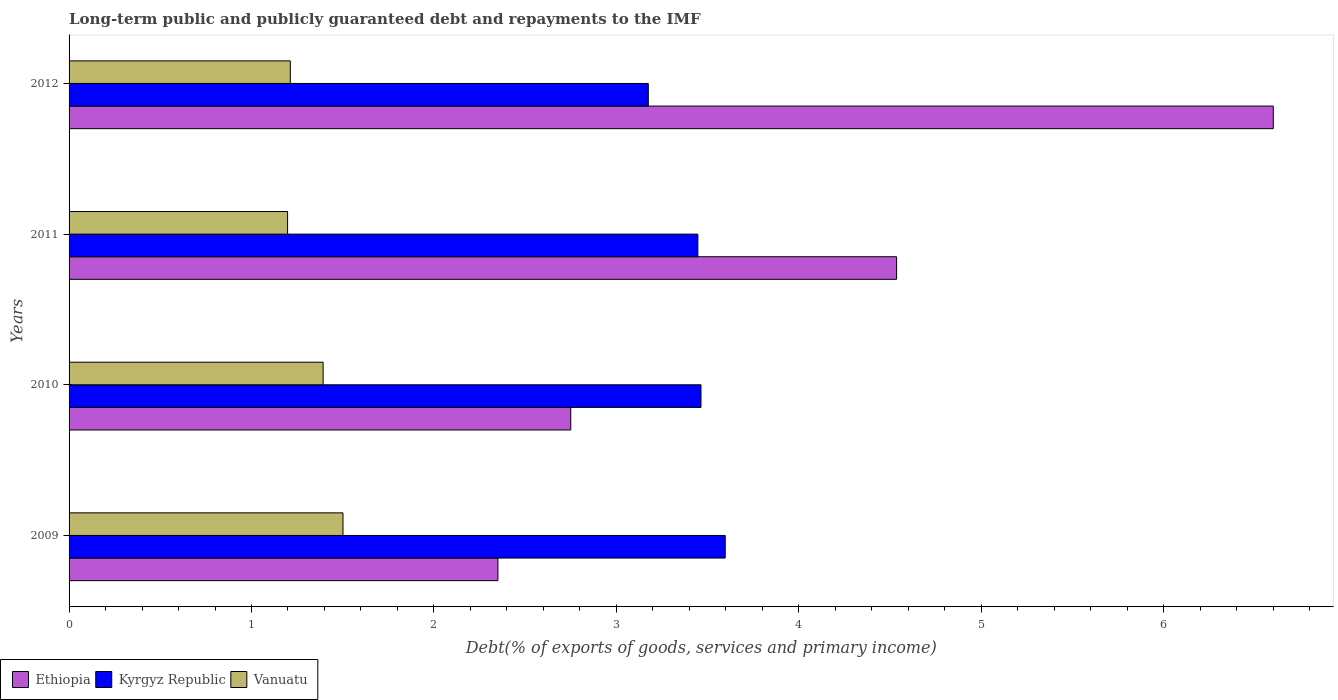How many different coloured bars are there?
Provide a short and direct response. 3. How many bars are there on the 3rd tick from the top?
Provide a succinct answer. 3. How many bars are there on the 4th tick from the bottom?
Your answer should be very brief. 3. What is the debt and repayments in Kyrgyz Republic in 2009?
Offer a terse response. 3.6. Across all years, what is the maximum debt and repayments in Ethiopia?
Make the answer very short. 6.6. Across all years, what is the minimum debt and repayments in Vanuatu?
Keep it short and to the point. 1.2. What is the total debt and repayments in Ethiopia in the graph?
Ensure brevity in your answer.  16.24. What is the difference between the debt and repayments in Kyrgyz Republic in 2009 and that in 2012?
Make the answer very short. 0.42. What is the difference between the debt and repayments in Ethiopia in 2009 and the debt and repayments in Kyrgyz Republic in 2011?
Your answer should be very brief. -1.1. What is the average debt and repayments in Ethiopia per year?
Offer a very short reply. 4.06. In the year 2010, what is the difference between the debt and repayments in Vanuatu and debt and repayments in Ethiopia?
Offer a terse response. -1.36. What is the ratio of the debt and repayments in Kyrgyz Republic in 2011 to that in 2012?
Ensure brevity in your answer.  1.09. Is the debt and repayments in Vanuatu in 2011 less than that in 2012?
Make the answer very short. Yes. Is the difference between the debt and repayments in Vanuatu in 2010 and 2011 greater than the difference between the debt and repayments in Ethiopia in 2010 and 2011?
Provide a succinct answer. Yes. What is the difference between the highest and the second highest debt and repayments in Kyrgyz Republic?
Keep it short and to the point. 0.13. What is the difference between the highest and the lowest debt and repayments in Ethiopia?
Your answer should be very brief. 4.25. In how many years, is the debt and repayments in Vanuatu greater than the average debt and repayments in Vanuatu taken over all years?
Offer a terse response. 2. What does the 3rd bar from the top in 2011 represents?
Provide a short and direct response. Ethiopia. What does the 2nd bar from the bottom in 2012 represents?
Your answer should be compact. Kyrgyz Republic. Is it the case that in every year, the sum of the debt and repayments in Kyrgyz Republic and debt and repayments in Vanuatu is greater than the debt and repayments in Ethiopia?
Provide a succinct answer. No. How many bars are there?
Ensure brevity in your answer.  12. How many years are there in the graph?
Ensure brevity in your answer.  4. Are the values on the major ticks of X-axis written in scientific E-notation?
Give a very brief answer. No. Does the graph contain grids?
Provide a succinct answer. No. Where does the legend appear in the graph?
Ensure brevity in your answer.  Bottom left. What is the title of the graph?
Your answer should be very brief. Long-term public and publicly guaranteed debt and repayments to the IMF. Does "Rwanda" appear as one of the legend labels in the graph?
Make the answer very short. No. What is the label or title of the X-axis?
Make the answer very short. Debt(% of exports of goods, services and primary income). What is the label or title of the Y-axis?
Provide a succinct answer. Years. What is the Debt(% of exports of goods, services and primary income) of Ethiopia in 2009?
Provide a short and direct response. 2.35. What is the Debt(% of exports of goods, services and primary income) in Kyrgyz Republic in 2009?
Provide a short and direct response. 3.6. What is the Debt(% of exports of goods, services and primary income) of Vanuatu in 2009?
Your response must be concise. 1.5. What is the Debt(% of exports of goods, services and primary income) of Ethiopia in 2010?
Provide a short and direct response. 2.75. What is the Debt(% of exports of goods, services and primary income) in Kyrgyz Republic in 2010?
Your response must be concise. 3.46. What is the Debt(% of exports of goods, services and primary income) of Vanuatu in 2010?
Offer a terse response. 1.39. What is the Debt(% of exports of goods, services and primary income) of Ethiopia in 2011?
Provide a succinct answer. 4.54. What is the Debt(% of exports of goods, services and primary income) in Kyrgyz Republic in 2011?
Make the answer very short. 3.45. What is the Debt(% of exports of goods, services and primary income) of Vanuatu in 2011?
Your answer should be compact. 1.2. What is the Debt(% of exports of goods, services and primary income) in Ethiopia in 2012?
Provide a succinct answer. 6.6. What is the Debt(% of exports of goods, services and primary income) in Kyrgyz Republic in 2012?
Provide a succinct answer. 3.18. What is the Debt(% of exports of goods, services and primary income) of Vanuatu in 2012?
Your response must be concise. 1.21. Across all years, what is the maximum Debt(% of exports of goods, services and primary income) in Ethiopia?
Keep it short and to the point. 6.6. Across all years, what is the maximum Debt(% of exports of goods, services and primary income) in Kyrgyz Republic?
Your answer should be compact. 3.6. Across all years, what is the maximum Debt(% of exports of goods, services and primary income) of Vanuatu?
Provide a short and direct response. 1.5. Across all years, what is the minimum Debt(% of exports of goods, services and primary income) in Ethiopia?
Keep it short and to the point. 2.35. Across all years, what is the minimum Debt(% of exports of goods, services and primary income) of Kyrgyz Republic?
Provide a succinct answer. 3.18. Across all years, what is the minimum Debt(% of exports of goods, services and primary income) of Vanuatu?
Your answer should be compact. 1.2. What is the total Debt(% of exports of goods, services and primary income) of Ethiopia in the graph?
Provide a short and direct response. 16.24. What is the total Debt(% of exports of goods, services and primary income) in Kyrgyz Republic in the graph?
Give a very brief answer. 13.68. What is the total Debt(% of exports of goods, services and primary income) of Vanuatu in the graph?
Your answer should be very brief. 5.3. What is the difference between the Debt(% of exports of goods, services and primary income) in Ethiopia in 2009 and that in 2010?
Your response must be concise. -0.4. What is the difference between the Debt(% of exports of goods, services and primary income) in Kyrgyz Republic in 2009 and that in 2010?
Offer a terse response. 0.13. What is the difference between the Debt(% of exports of goods, services and primary income) in Vanuatu in 2009 and that in 2010?
Your answer should be very brief. 0.11. What is the difference between the Debt(% of exports of goods, services and primary income) of Ethiopia in 2009 and that in 2011?
Ensure brevity in your answer.  -2.19. What is the difference between the Debt(% of exports of goods, services and primary income) in Kyrgyz Republic in 2009 and that in 2011?
Ensure brevity in your answer.  0.15. What is the difference between the Debt(% of exports of goods, services and primary income) in Vanuatu in 2009 and that in 2011?
Ensure brevity in your answer.  0.3. What is the difference between the Debt(% of exports of goods, services and primary income) in Ethiopia in 2009 and that in 2012?
Your response must be concise. -4.25. What is the difference between the Debt(% of exports of goods, services and primary income) in Kyrgyz Republic in 2009 and that in 2012?
Your answer should be very brief. 0.42. What is the difference between the Debt(% of exports of goods, services and primary income) of Vanuatu in 2009 and that in 2012?
Offer a terse response. 0.29. What is the difference between the Debt(% of exports of goods, services and primary income) of Ethiopia in 2010 and that in 2011?
Ensure brevity in your answer.  -1.79. What is the difference between the Debt(% of exports of goods, services and primary income) in Kyrgyz Republic in 2010 and that in 2011?
Keep it short and to the point. 0.02. What is the difference between the Debt(% of exports of goods, services and primary income) in Vanuatu in 2010 and that in 2011?
Give a very brief answer. 0.19. What is the difference between the Debt(% of exports of goods, services and primary income) of Ethiopia in 2010 and that in 2012?
Offer a very short reply. -3.85. What is the difference between the Debt(% of exports of goods, services and primary income) of Kyrgyz Republic in 2010 and that in 2012?
Your answer should be compact. 0.29. What is the difference between the Debt(% of exports of goods, services and primary income) of Vanuatu in 2010 and that in 2012?
Your answer should be very brief. 0.18. What is the difference between the Debt(% of exports of goods, services and primary income) of Ethiopia in 2011 and that in 2012?
Your response must be concise. -2.06. What is the difference between the Debt(% of exports of goods, services and primary income) of Kyrgyz Republic in 2011 and that in 2012?
Give a very brief answer. 0.27. What is the difference between the Debt(% of exports of goods, services and primary income) in Vanuatu in 2011 and that in 2012?
Keep it short and to the point. -0.01. What is the difference between the Debt(% of exports of goods, services and primary income) in Ethiopia in 2009 and the Debt(% of exports of goods, services and primary income) in Kyrgyz Republic in 2010?
Offer a very short reply. -1.11. What is the difference between the Debt(% of exports of goods, services and primary income) of Ethiopia in 2009 and the Debt(% of exports of goods, services and primary income) of Vanuatu in 2010?
Provide a succinct answer. 0.96. What is the difference between the Debt(% of exports of goods, services and primary income) in Kyrgyz Republic in 2009 and the Debt(% of exports of goods, services and primary income) in Vanuatu in 2010?
Ensure brevity in your answer.  2.2. What is the difference between the Debt(% of exports of goods, services and primary income) of Ethiopia in 2009 and the Debt(% of exports of goods, services and primary income) of Kyrgyz Republic in 2011?
Your answer should be compact. -1.1. What is the difference between the Debt(% of exports of goods, services and primary income) in Ethiopia in 2009 and the Debt(% of exports of goods, services and primary income) in Vanuatu in 2011?
Your answer should be compact. 1.15. What is the difference between the Debt(% of exports of goods, services and primary income) of Kyrgyz Republic in 2009 and the Debt(% of exports of goods, services and primary income) of Vanuatu in 2011?
Provide a succinct answer. 2.4. What is the difference between the Debt(% of exports of goods, services and primary income) of Ethiopia in 2009 and the Debt(% of exports of goods, services and primary income) of Kyrgyz Republic in 2012?
Keep it short and to the point. -0.82. What is the difference between the Debt(% of exports of goods, services and primary income) of Ethiopia in 2009 and the Debt(% of exports of goods, services and primary income) of Vanuatu in 2012?
Offer a very short reply. 1.14. What is the difference between the Debt(% of exports of goods, services and primary income) of Kyrgyz Republic in 2009 and the Debt(% of exports of goods, services and primary income) of Vanuatu in 2012?
Provide a succinct answer. 2.38. What is the difference between the Debt(% of exports of goods, services and primary income) of Ethiopia in 2010 and the Debt(% of exports of goods, services and primary income) of Kyrgyz Republic in 2011?
Ensure brevity in your answer.  -0.7. What is the difference between the Debt(% of exports of goods, services and primary income) in Ethiopia in 2010 and the Debt(% of exports of goods, services and primary income) in Vanuatu in 2011?
Keep it short and to the point. 1.55. What is the difference between the Debt(% of exports of goods, services and primary income) of Kyrgyz Republic in 2010 and the Debt(% of exports of goods, services and primary income) of Vanuatu in 2011?
Keep it short and to the point. 2.27. What is the difference between the Debt(% of exports of goods, services and primary income) in Ethiopia in 2010 and the Debt(% of exports of goods, services and primary income) in Kyrgyz Republic in 2012?
Ensure brevity in your answer.  -0.43. What is the difference between the Debt(% of exports of goods, services and primary income) in Ethiopia in 2010 and the Debt(% of exports of goods, services and primary income) in Vanuatu in 2012?
Offer a terse response. 1.54. What is the difference between the Debt(% of exports of goods, services and primary income) of Kyrgyz Republic in 2010 and the Debt(% of exports of goods, services and primary income) of Vanuatu in 2012?
Make the answer very short. 2.25. What is the difference between the Debt(% of exports of goods, services and primary income) in Ethiopia in 2011 and the Debt(% of exports of goods, services and primary income) in Kyrgyz Republic in 2012?
Ensure brevity in your answer.  1.36. What is the difference between the Debt(% of exports of goods, services and primary income) of Ethiopia in 2011 and the Debt(% of exports of goods, services and primary income) of Vanuatu in 2012?
Offer a very short reply. 3.32. What is the difference between the Debt(% of exports of goods, services and primary income) in Kyrgyz Republic in 2011 and the Debt(% of exports of goods, services and primary income) in Vanuatu in 2012?
Give a very brief answer. 2.23. What is the average Debt(% of exports of goods, services and primary income) in Ethiopia per year?
Ensure brevity in your answer.  4.06. What is the average Debt(% of exports of goods, services and primary income) of Kyrgyz Republic per year?
Keep it short and to the point. 3.42. What is the average Debt(% of exports of goods, services and primary income) of Vanuatu per year?
Offer a terse response. 1.33. In the year 2009, what is the difference between the Debt(% of exports of goods, services and primary income) in Ethiopia and Debt(% of exports of goods, services and primary income) in Kyrgyz Republic?
Make the answer very short. -1.25. In the year 2009, what is the difference between the Debt(% of exports of goods, services and primary income) of Ethiopia and Debt(% of exports of goods, services and primary income) of Vanuatu?
Offer a terse response. 0.85. In the year 2009, what is the difference between the Debt(% of exports of goods, services and primary income) in Kyrgyz Republic and Debt(% of exports of goods, services and primary income) in Vanuatu?
Ensure brevity in your answer.  2.1. In the year 2010, what is the difference between the Debt(% of exports of goods, services and primary income) of Ethiopia and Debt(% of exports of goods, services and primary income) of Kyrgyz Republic?
Offer a very short reply. -0.71. In the year 2010, what is the difference between the Debt(% of exports of goods, services and primary income) in Ethiopia and Debt(% of exports of goods, services and primary income) in Vanuatu?
Provide a short and direct response. 1.36. In the year 2010, what is the difference between the Debt(% of exports of goods, services and primary income) of Kyrgyz Republic and Debt(% of exports of goods, services and primary income) of Vanuatu?
Provide a succinct answer. 2.07. In the year 2011, what is the difference between the Debt(% of exports of goods, services and primary income) of Ethiopia and Debt(% of exports of goods, services and primary income) of Kyrgyz Republic?
Your response must be concise. 1.09. In the year 2011, what is the difference between the Debt(% of exports of goods, services and primary income) of Ethiopia and Debt(% of exports of goods, services and primary income) of Vanuatu?
Your response must be concise. 3.34. In the year 2011, what is the difference between the Debt(% of exports of goods, services and primary income) in Kyrgyz Republic and Debt(% of exports of goods, services and primary income) in Vanuatu?
Your response must be concise. 2.25. In the year 2012, what is the difference between the Debt(% of exports of goods, services and primary income) in Ethiopia and Debt(% of exports of goods, services and primary income) in Kyrgyz Republic?
Your response must be concise. 3.43. In the year 2012, what is the difference between the Debt(% of exports of goods, services and primary income) in Ethiopia and Debt(% of exports of goods, services and primary income) in Vanuatu?
Your answer should be compact. 5.39. In the year 2012, what is the difference between the Debt(% of exports of goods, services and primary income) of Kyrgyz Republic and Debt(% of exports of goods, services and primary income) of Vanuatu?
Offer a terse response. 1.96. What is the ratio of the Debt(% of exports of goods, services and primary income) of Ethiopia in 2009 to that in 2010?
Make the answer very short. 0.85. What is the ratio of the Debt(% of exports of goods, services and primary income) of Kyrgyz Republic in 2009 to that in 2010?
Your answer should be compact. 1.04. What is the ratio of the Debt(% of exports of goods, services and primary income) in Vanuatu in 2009 to that in 2010?
Offer a terse response. 1.08. What is the ratio of the Debt(% of exports of goods, services and primary income) in Ethiopia in 2009 to that in 2011?
Offer a terse response. 0.52. What is the ratio of the Debt(% of exports of goods, services and primary income) in Kyrgyz Republic in 2009 to that in 2011?
Provide a short and direct response. 1.04. What is the ratio of the Debt(% of exports of goods, services and primary income) in Vanuatu in 2009 to that in 2011?
Provide a succinct answer. 1.25. What is the ratio of the Debt(% of exports of goods, services and primary income) of Ethiopia in 2009 to that in 2012?
Your answer should be compact. 0.36. What is the ratio of the Debt(% of exports of goods, services and primary income) in Kyrgyz Republic in 2009 to that in 2012?
Your answer should be very brief. 1.13. What is the ratio of the Debt(% of exports of goods, services and primary income) in Vanuatu in 2009 to that in 2012?
Provide a short and direct response. 1.24. What is the ratio of the Debt(% of exports of goods, services and primary income) in Ethiopia in 2010 to that in 2011?
Offer a terse response. 0.61. What is the ratio of the Debt(% of exports of goods, services and primary income) in Vanuatu in 2010 to that in 2011?
Your answer should be very brief. 1.16. What is the ratio of the Debt(% of exports of goods, services and primary income) of Ethiopia in 2010 to that in 2012?
Your response must be concise. 0.42. What is the ratio of the Debt(% of exports of goods, services and primary income) of Kyrgyz Republic in 2010 to that in 2012?
Provide a succinct answer. 1.09. What is the ratio of the Debt(% of exports of goods, services and primary income) of Vanuatu in 2010 to that in 2012?
Ensure brevity in your answer.  1.15. What is the ratio of the Debt(% of exports of goods, services and primary income) of Ethiopia in 2011 to that in 2012?
Your response must be concise. 0.69. What is the ratio of the Debt(% of exports of goods, services and primary income) in Kyrgyz Republic in 2011 to that in 2012?
Offer a very short reply. 1.09. What is the difference between the highest and the second highest Debt(% of exports of goods, services and primary income) in Ethiopia?
Offer a terse response. 2.06. What is the difference between the highest and the second highest Debt(% of exports of goods, services and primary income) of Kyrgyz Republic?
Provide a short and direct response. 0.13. What is the difference between the highest and the second highest Debt(% of exports of goods, services and primary income) of Vanuatu?
Offer a very short reply. 0.11. What is the difference between the highest and the lowest Debt(% of exports of goods, services and primary income) of Ethiopia?
Your answer should be compact. 4.25. What is the difference between the highest and the lowest Debt(% of exports of goods, services and primary income) in Kyrgyz Republic?
Keep it short and to the point. 0.42. What is the difference between the highest and the lowest Debt(% of exports of goods, services and primary income) of Vanuatu?
Your answer should be very brief. 0.3. 